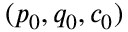Convert formula to latex. <formula><loc_0><loc_0><loc_500><loc_500>( p _ { 0 } , q _ { 0 } , c _ { 0 } )</formula> 